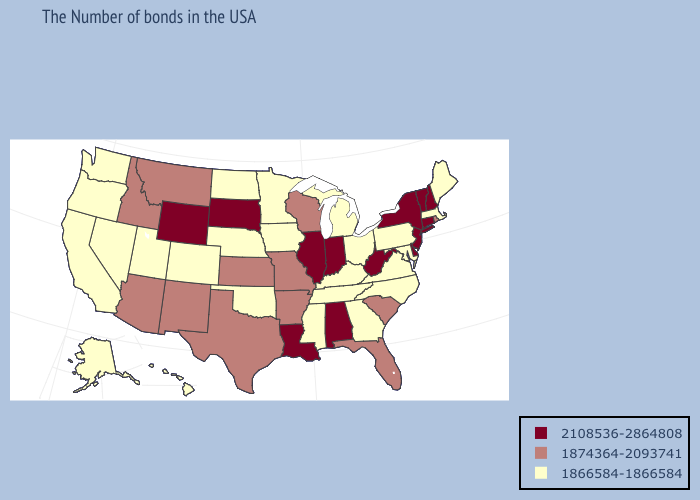Is the legend a continuous bar?
Answer briefly. No. Does Nevada have a lower value than Arkansas?
Quick response, please. Yes. What is the highest value in states that border Illinois?
Answer briefly. 2108536-2864808. Name the states that have a value in the range 1874364-2093741?
Keep it brief. Rhode Island, South Carolina, Florida, Wisconsin, Missouri, Arkansas, Kansas, Texas, New Mexico, Montana, Arizona, Idaho. What is the value of Minnesota?
Be succinct. 1866584-1866584. What is the lowest value in the USA?
Answer briefly. 1866584-1866584. Name the states that have a value in the range 1866584-1866584?
Give a very brief answer. Maine, Massachusetts, Maryland, Pennsylvania, Virginia, North Carolina, Ohio, Georgia, Michigan, Kentucky, Tennessee, Mississippi, Minnesota, Iowa, Nebraska, Oklahoma, North Dakota, Colorado, Utah, Nevada, California, Washington, Oregon, Alaska, Hawaii. What is the value of Nebraska?
Be succinct. 1866584-1866584. What is the value of Texas?
Quick response, please. 1874364-2093741. What is the value of Arizona?
Write a very short answer. 1874364-2093741. How many symbols are there in the legend?
Give a very brief answer. 3. Which states hav the highest value in the West?
Keep it brief. Wyoming. What is the highest value in states that border Maryland?
Concise answer only. 2108536-2864808. Name the states that have a value in the range 1866584-1866584?
Quick response, please. Maine, Massachusetts, Maryland, Pennsylvania, Virginia, North Carolina, Ohio, Georgia, Michigan, Kentucky, Tennessee, Mississippi, Minnesota, Iowa, Nebraska, Oklahoma, North Dakota, Colorado, Utah, Nevada, California, Washington, Oregon, Alaska, Hawaii. What is the value of Minnesota?
Give a very brief answer. 1866584-1866584. 